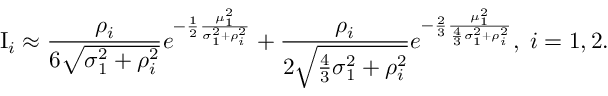Convert formula to latex. <formula><loc_0><loc_0><loc_500><loc_500>I _ { i } \approx \frac { \rho _ { i } } { 6 \sqrt { \sigma _ { 1 } ^ { 2 } + \rho _ { i } ^ { 2 } } } e ^ { - \frac { 1 } { 2 } \frac { \mu _ { 1 } ^ { 2 } } { \sigma _ { 1 } ^ { 2 } + \rho _ { i } ^ { 2 } } } + \frac { \rho _ { i } } { 2 \sqrt { \frac { 4 } { 3 } \sigma _ { 1 } ^ { 2 } + \rho _ { i } ^ { 2 } } } e ^ { - \frac { 2 } { 3 } \frac { \mu _ { 1 } ^ { 2 } } { \frac { 4 } { 3 } \sigma _ { 1 } ^ { 2 } + \rho _ { i } ^ { 2 } } } , \, i = 1 , 2 .</formula> 